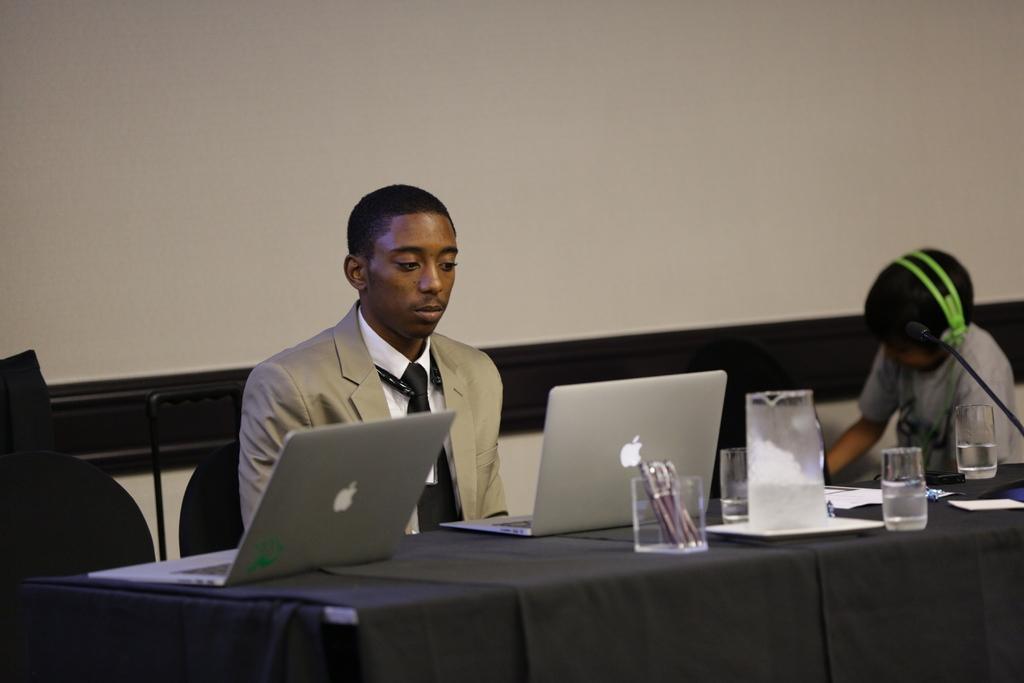Could you give a brief overview of what you see in this image? The two persons are sitting on a chair. There is a table. There is a laptop,glass and pen box on a table. 